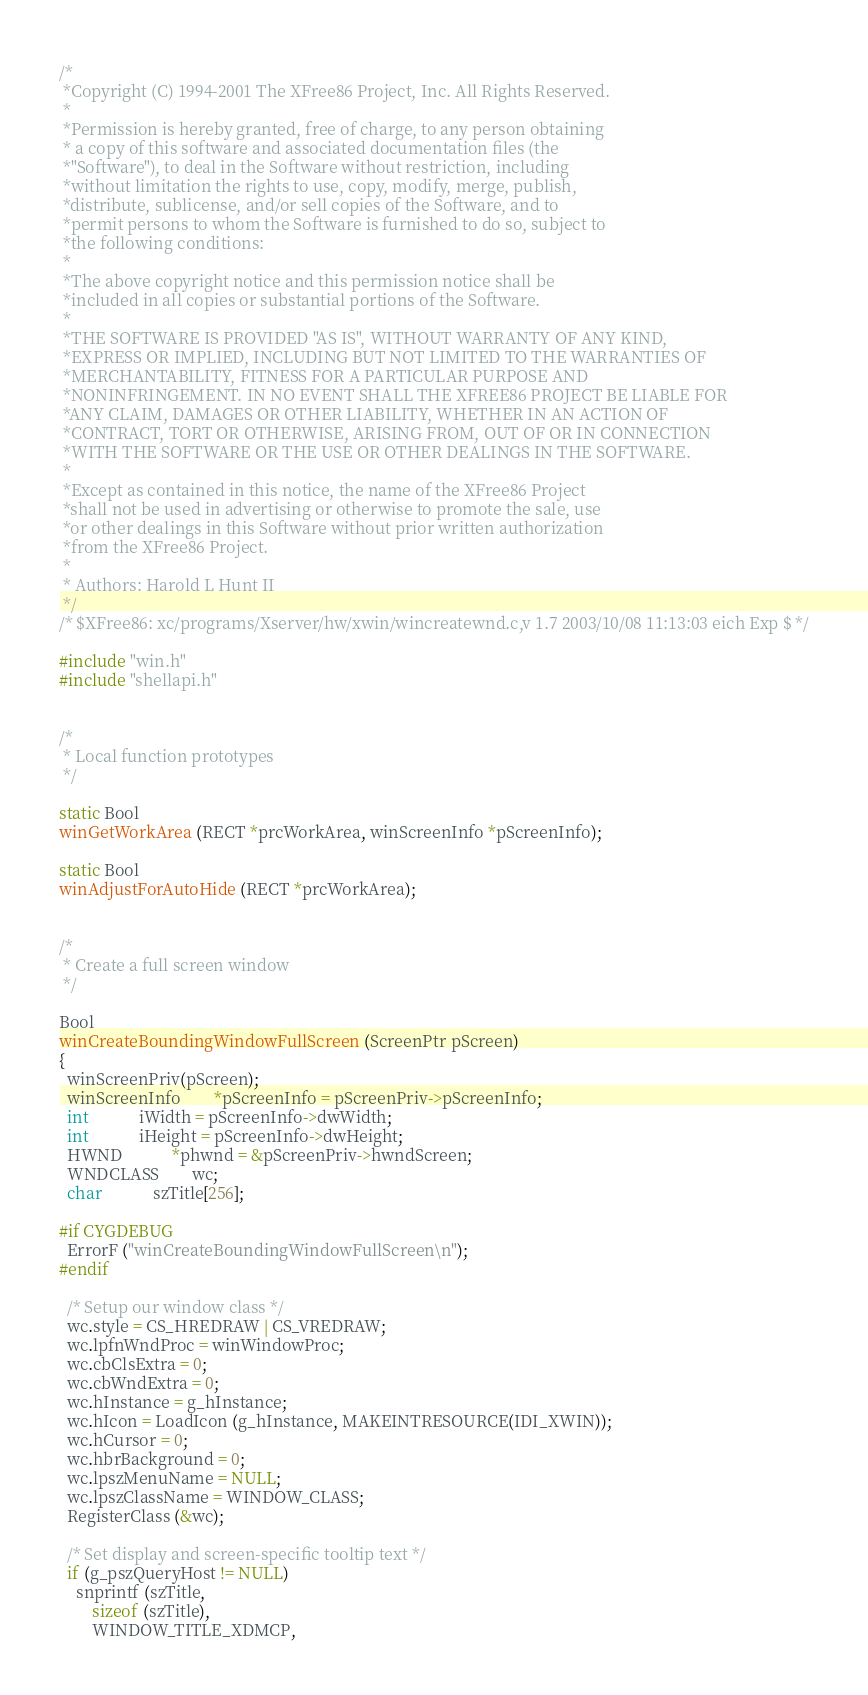<code> <loc_0><loc_0><loc_500><loc_500><_C_>/*
 *Copyright (C) 1994-2001 The XFree86 Project, Inc. All Rights Reserved.
 *
 *Permission is hereby granted, free of charge, to any person obtaining
 * a copy of this software and associated documentation files (the
 *"Software"), to deal in the Software without restriction, including
 *without limitation the rights to use, copy, modify, merge, publish,
 *distribute, sublicense, and/or sell copies of the Software, and to
 *permit persons to whom the Software is furnished to do so, subject to
 *the following conditions:
 *
 *The above copyright notice and this permission notice shall be
 *included in all copies or substantial portions of the Software.
 *
 *THE SOFTWARE IS PROVIDED "AS IS", WITHOUT WARRANTY OF ANY KIND,
 *EXPRESS OR IMPLIED, INCLUDING BUT NOT LIMITED TO THE WARRANTIES OF
 *MERCHANTABILITY, FITNESS FOR A PARTICULAR PURPOSE AND
 *NONINFRINGEMENT. IN NO EVENT SHALL THE XFREE86 PROJECT BE LIABLE FOR
 *ANY CLAIM, DAMAGES OR OTHER LIABILITY, WHETHER IN AN ACTION OF
 *CONTRACT, TORT OR OTHERWISE, ARISING FROM, OUT OF OR IN CONNECTION
 *WITH THE SOFTWARE OR THE USE OR OTHER DEALINGS IN THE SOFTWARE.
 *
 *Except as contained in this notice, the name of the XFree86 Project
 *shall not be used in advertising or otherwise to promote the sale, use
 *or other dealings in this Software without prior written authorization
 *from the XFree86 Project.
 *
 * Authors:	Harold L Hunt II
 */
/* $XFree86: xc/programs/Xserver/hw/xwin/wincreatewnd.c,v 1.7 2003/10/08 11:13:03 eich Exp $ */

#include "win.h"
#include "shellapi.h"


/*
 * Local function prototypes
 */

static Bool
winGetWorkArea (RECT *prcWorkArea, winScreenInfo *pScreenInfo);

static Bool
winAdjustForAutoHide (RECT *prcWorkArea);


/*
 * Create a full screen window
 */

Bool
winCreateBoundingWindowFullScreen (ScreenPtr pScreen)
{
  winScreenPriv(pScreen);
  winScreenInfo		*pScreenInfo = pScreenPriv->pScreenInfo;
  int			iWidth = pScreenInfo->dwWidth;
  int			iHeight = pScreenInfo->dwHeight;
  HWND			*phwnd = &pScreenPriv->hwndScreen;
  WNDCLASS		wc;
  char			szTitle[256];

#if CYGDEBUG
  ErrorF ("winCreateBoundingWindowFullScreen\n");
#endif

  /* Setup our window class */
  wc.style = CS_HREDRAW | CS_VREDRAW;
  wc.lpfnWndProc = winWindowProc;
  wc.cbClsExtra = 0;
  wc.cbWndExtra = 0;
  wc.hInstance = g_hInstance;
  wc.hIcon = LoadIcon (g_hInstance, MAKEINTRESOURCE(IDI_XWIN));
  wc.hCursor = 0;
  wc.hbrBackground = 0;
  wc.lpszMenuName = NULL;
  wc.lpszClassName = WINDOW_CLASS;
  RegisterClass (&wc);

  /* Set display and screen-specific tooltip text */
  if (g_pszQueryHost != NULL)
    snprintf (szTitle,
	    sizeof (szTitle),
	    WINDOW_TITLE_XDMCP,</code> 